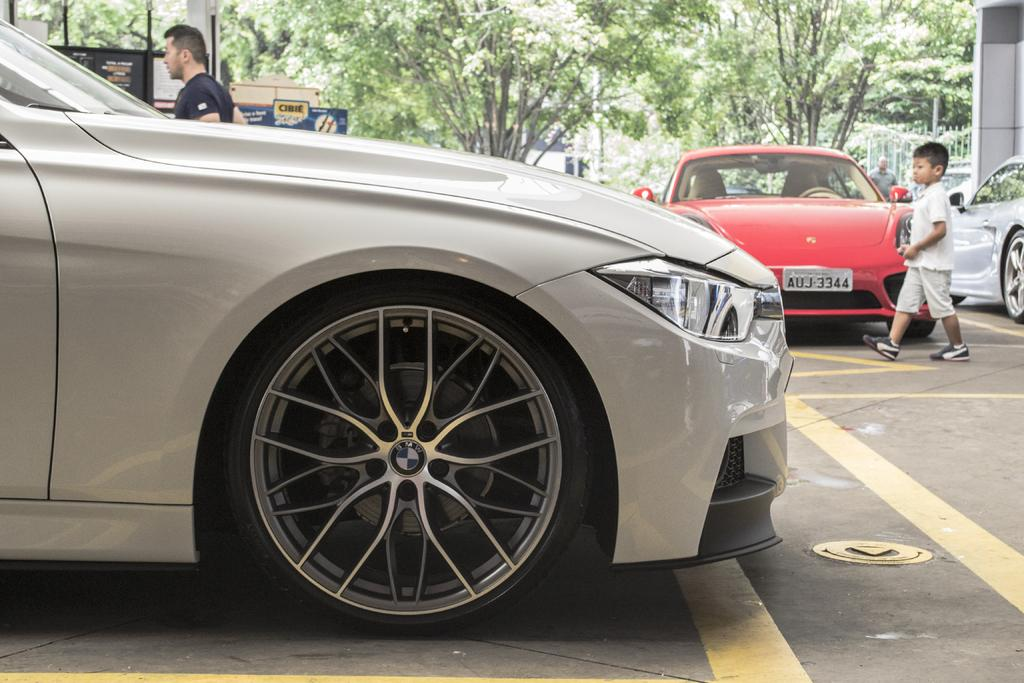What is the main subject in the center of the image? There are cars in the center of the image. Can you describe the people in the image? There is a man and a boy in the image. What type of natural elements can be seen in the image? There are trees in the image. What else can be seen in the image besides the cars, people, and trees? There are boards and a wall in the image. What is the setting of the image? There is a road at the bottom of the image, suggesting it might be an outdoor scene. What type of order is being processed at the stamp counter in the image? There is no stamp counter or order processing visible in the image. 